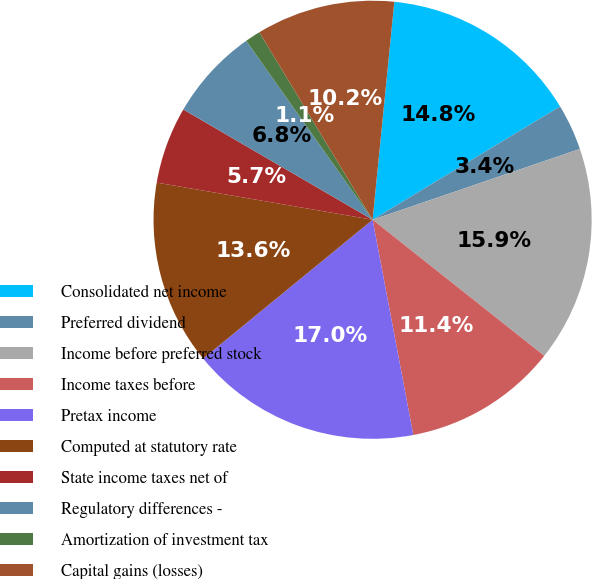Convert chart to OTSL. <chart><loc_0><loc_0><loc_500><loc_500><pie_chart><fcel>Consolidated net income<fcel>Preferred dividend<fcel>Income before preferred stock<fcel>Income taxes before<fcel>Pretax income<fcel>Computed at statutory rate<fcel>State income taxes net of<fcel>Regulatory differences -<fcel>Amortization of investment tax<fcel>Capital gains (losses)<nl><fcel>14.77%<fcel>3.41%<fcel>15.91%<fcel>11.36%<fcel>17.05%<fcel>13.64%<fcel>5.68%<fcel>6.82%<fcel>1.14%<fcel>10.23%<nl></chart> 